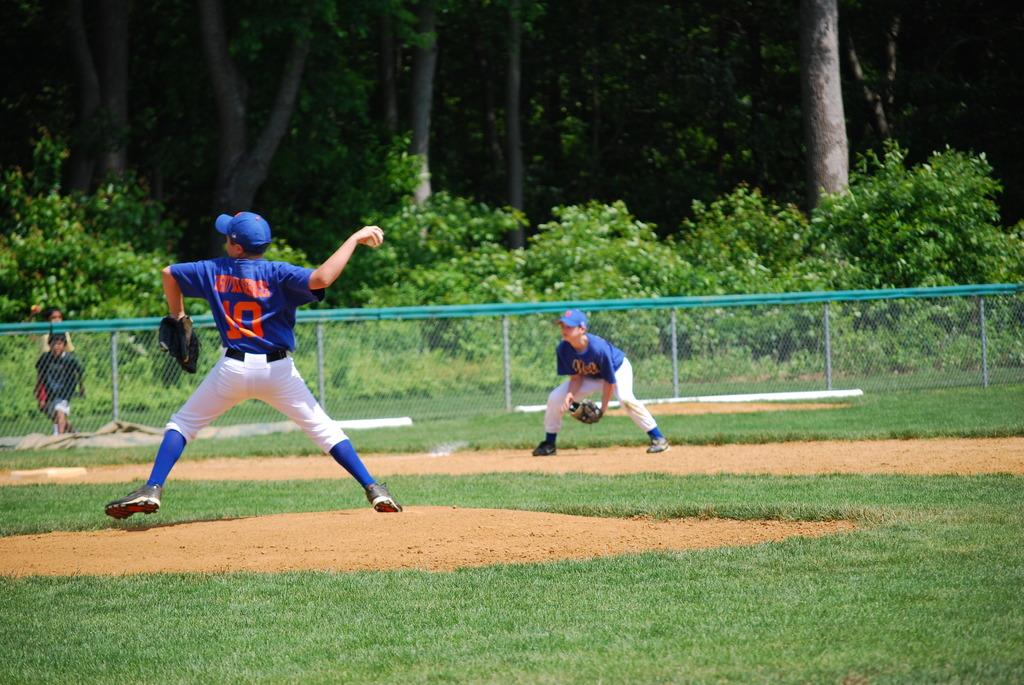<image>
Offer a succinct explanation of the picture presented. The number 10 player is at the mound throwing the baseball. 